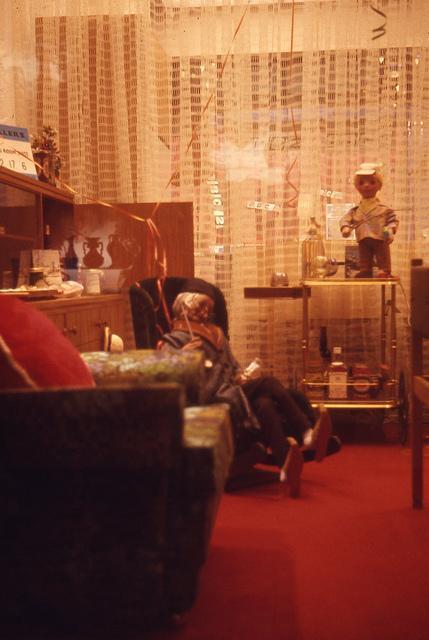How many chairs are visible?
Give a very brief answer. 2. 